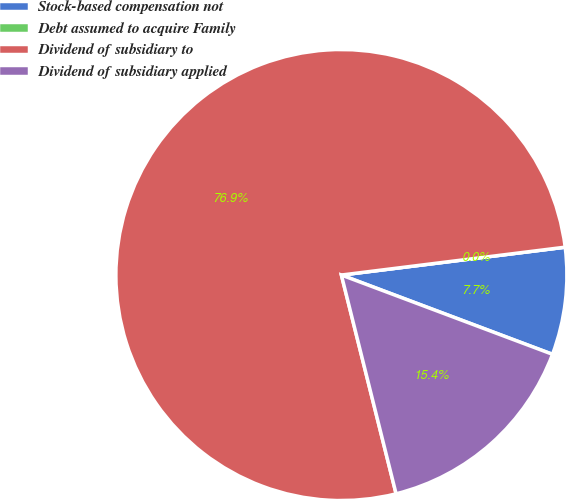Convert chart. <chart><loc_0><loc_0><loc_500><loc_500><pie_chart><fcel>Stock-based compensation not<fcel>Debt assumed to acquire Family<fcel>Dividend of subsidiary to<fcel>Dividend of subsidiary applied<nl><fcel>7.69%<fcel>0.0%<fcel>76.92%<fcel>15.38%<nl></chart> 